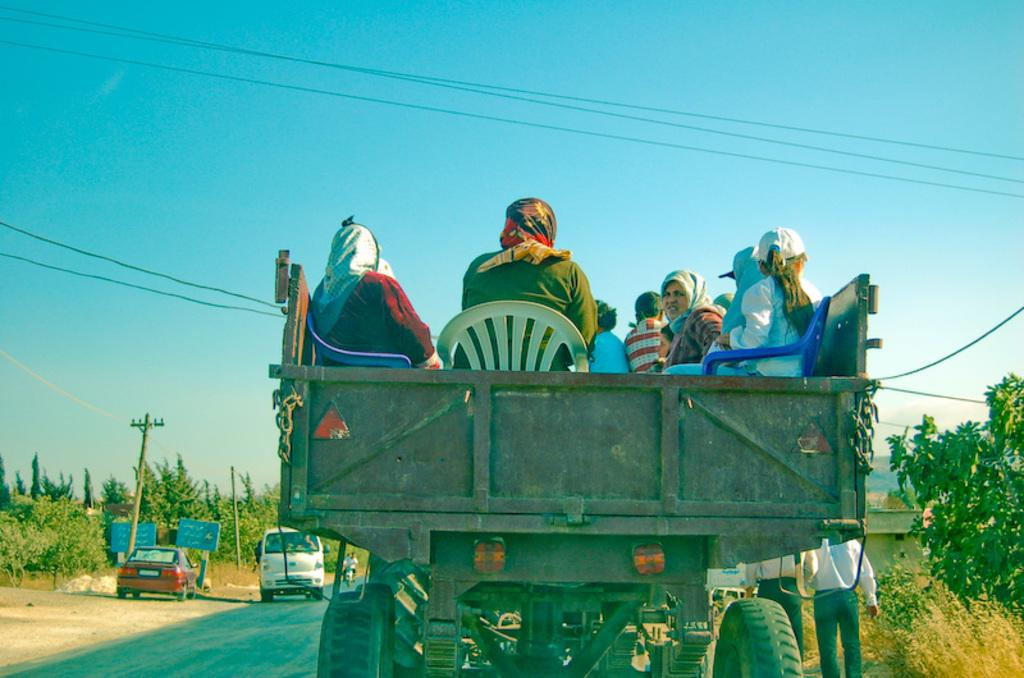What are the women doing in the image? The women are sitting in a truck. What is the truck doing in the image? The truck is moving on the road. What else can be seen on the road in the image? There are parked cars on the roadside. What is visible in the background of the image? The sky is visible in the image. What committee is meeting in the image? There is no committee meeting in the image; it features women sitting in a moving truck. Who are the friends sitting in the truck in the image? The provided facts do not mention any friends or relationships between the women in the truck. 